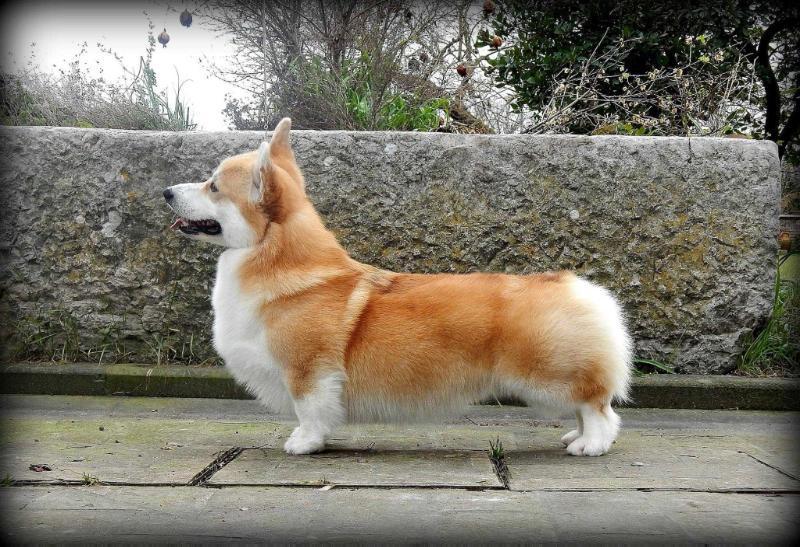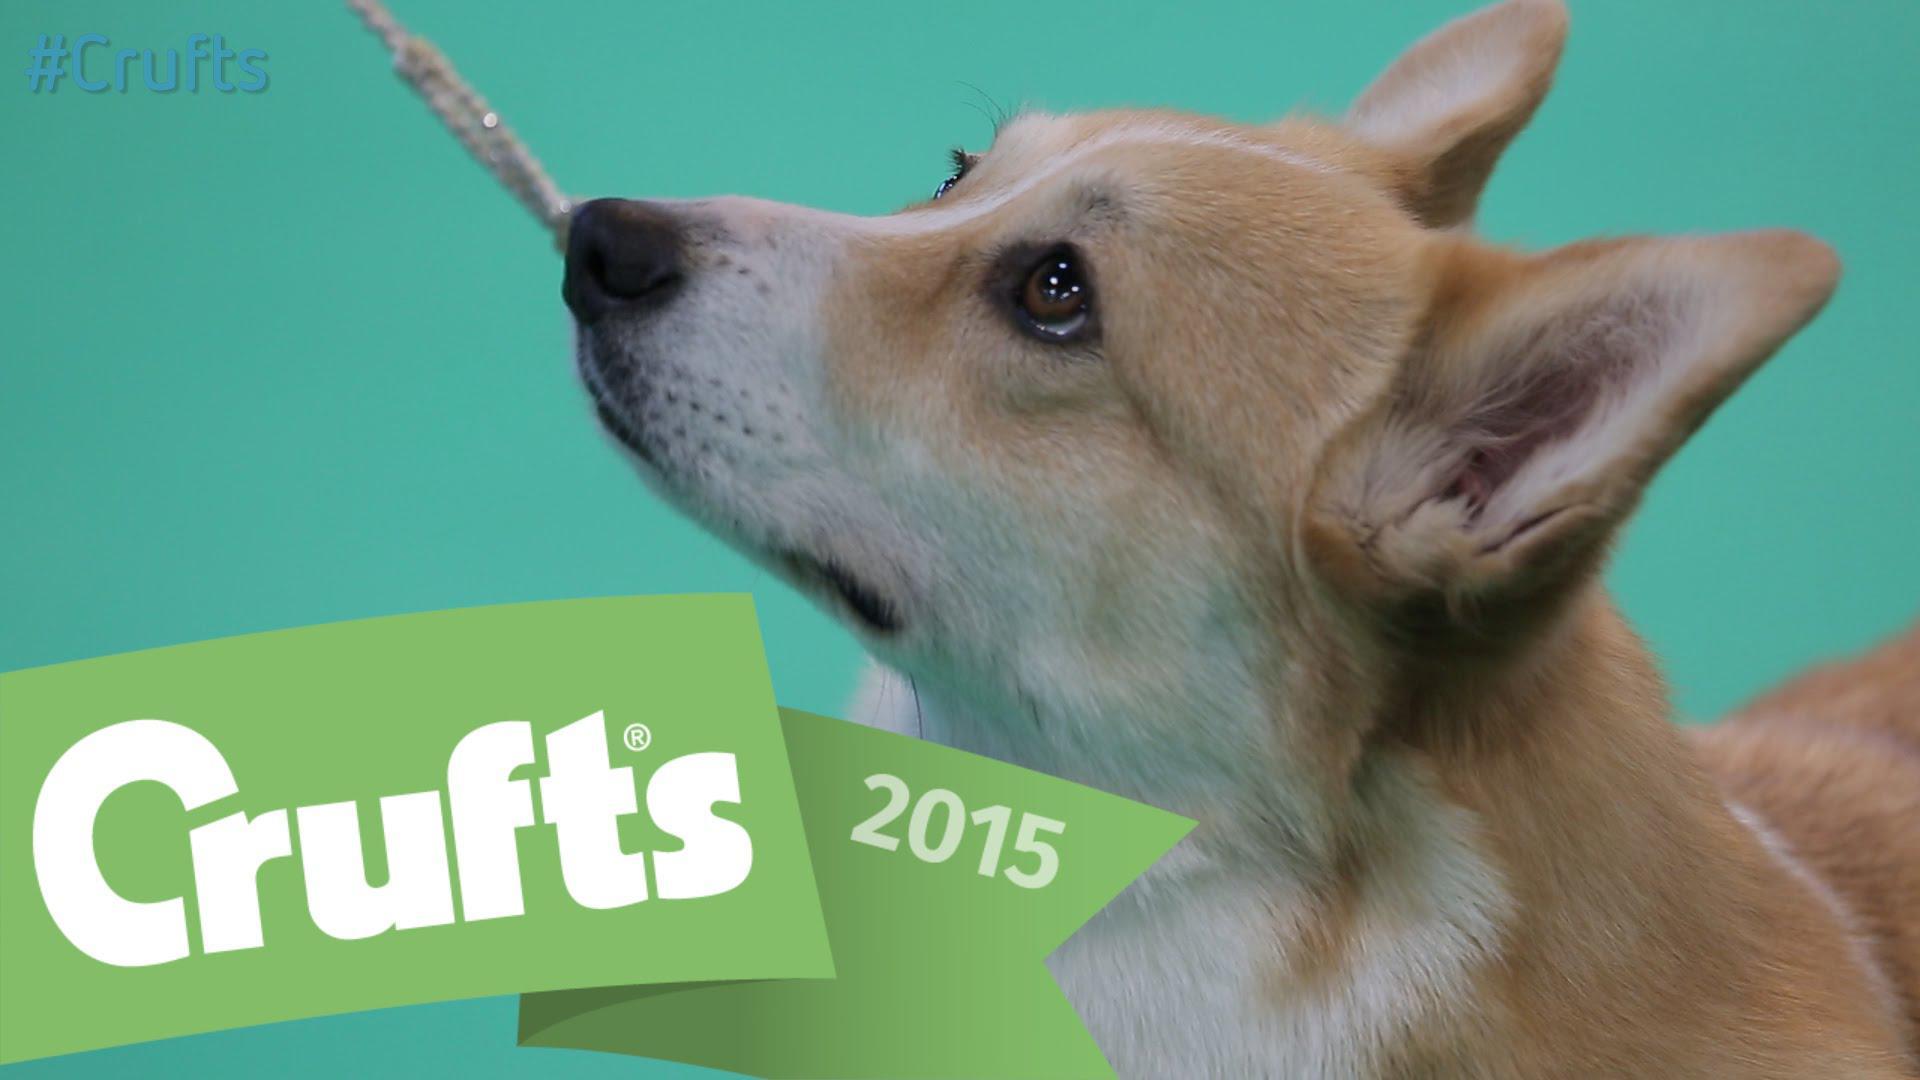The first image is the image on the left, the second image is the image on the right. For the images displayed, is the sentence "The dog in one of the images is standing on a small step placed on the floor." factually correct? Answer yes or no. No. 